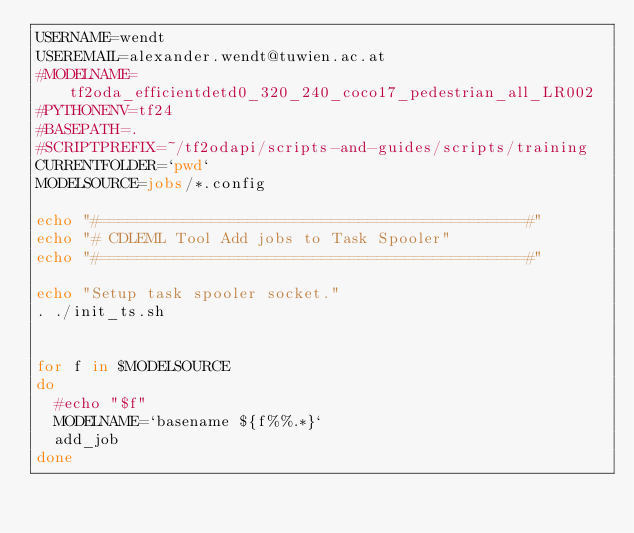Convert code to text. <code><loc_0><loc_0><loc_500><loc_500><_Bash_>USERNAME=wendt
USEREMAIL=alexander.wendt@tuwien.ac.at
#MODELNAME=tf2oda_efficientdetd0_320_240_coco17_pedestrian_all_LR002
#PYTHONENV=tf24
#BASEPATH=.
#SCRIPTPREFIX=~/tf2odapi/scripts-and-guides/scripts/training
CURRENTFOLDER=`pwd`
MODELSOURCE=jobs/*.config

echo "#==============================================#"
echo "# CDLEML Tool Add jobs to Task Spooler"
echo "#==============================================#"

echo "Setup task spooler socket."
. ./init_ts.sh


for f in $MODELSOURCE
do
  #echo "$f"
  MODELNAME=`basename ${f%%.*}`
  add_job
done

</code> 